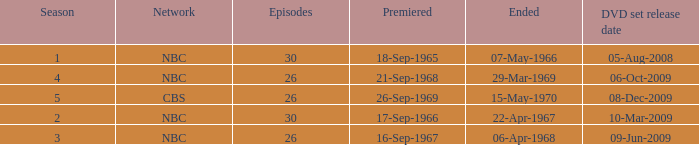When dis cbs release the DVD set? 08-Dec-2009. 